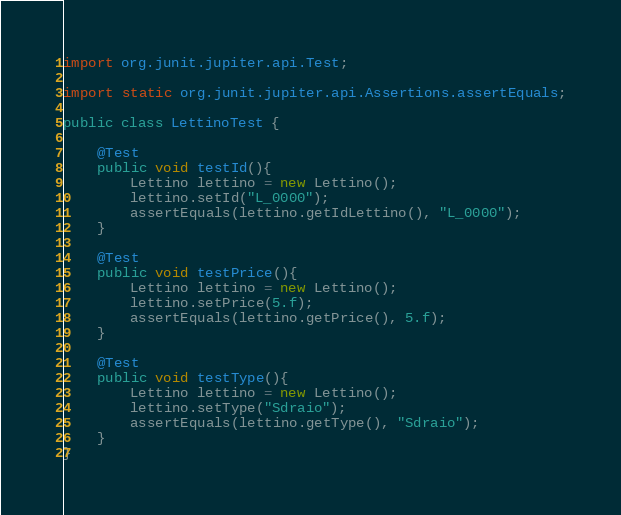<code> <loc_0><loc_0><loc_500><loc_500><_Java_>import org.junit.jupiter.api.Test;

import static org.junit.jupiter.api.Assertions.assertEquals;

public class LettinoTest {

    @Test
    public void testId(){
        Lettino lettino = new Lettino();
        lettino.setId("L_0000");
        assertEquals(lettino.getIdLettino(), "L_0000");
    }

    @Test
    public void testPrice(){
        Lettino lettino = new Lettino();
        lettino.setPrice(5.f);
        assertEquals(lettino.getPrice(), 5.f);
    }

    @Test
    public void testType(){
        Lettino lettino = new Lettino();
        lettino.setType("Sdraio");
        assertEquals(lettino.getType(), "Sdraio");
    }
}
</code> 